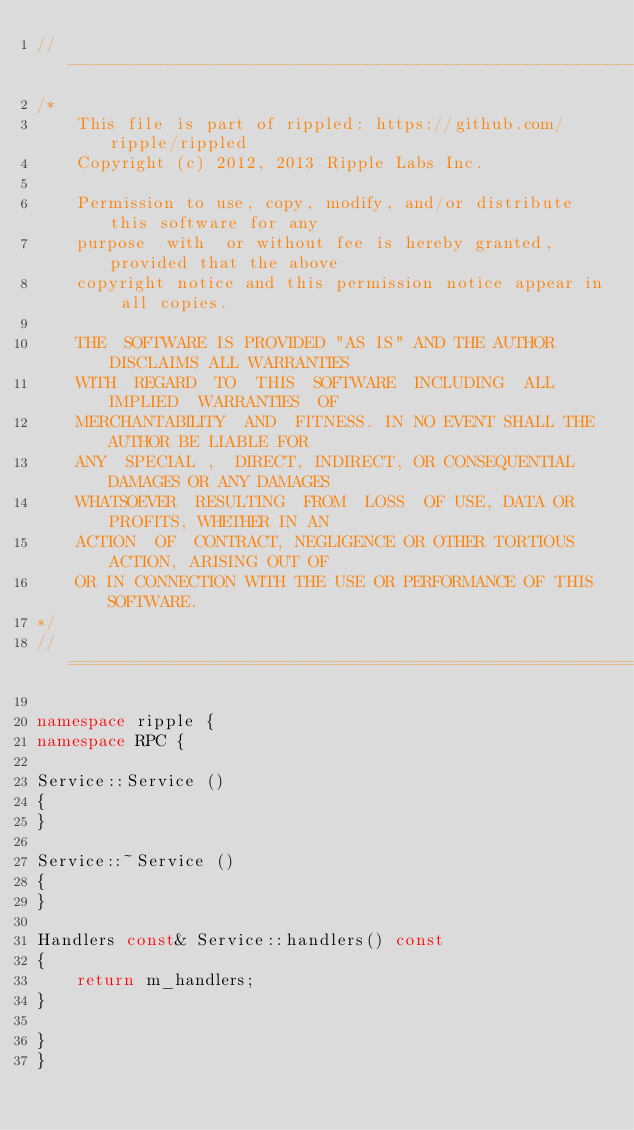<code> <loc_0><loc_0><loc_500><loc_500><_C++_>//------------------------------------------------------------------------------
/*
    This file is part of rippled: https://github.com/ripple/rippled
    Copyright (c) 2012, 2013 Ripple Labs Inc.

    Permission to use, copy, modify, and/or distribute this software for any
    purpose  with  or without fee is hereby granted, provided that the above
    copyright notice and this permission notice appear in all copies.

    THE  SOFTWARE IS PROVIDED "AS IS" AND THE AUTHOR DISCLAIMS ALL WARRANTIES
    WITH  REGARD  TO  THIS  SOFTWARE  INCLUDING  ALL  IMPLIED  WARRANTIES  OF
    MERCHANTABILITY  AND  FITNESS. IN NO EVENT SHALL THE AUTHOR BE LIABLE FOR
    ANY  SPECIAL ,  DIRECT, INDIRECT, OR CONSEQUENTIAL DAMAGES OR ANY DAMAGES
    WHATSOEVER  RESULTING  FROM  LOSS  OF USE, DATA OR PROFITS, WHETHER IN AN
    ACTION  OF  CONTRACT, NEGLIGENCE OR OTHER TORTIOUS ACTION, ARISING OUT OF
    OR IN CONNECTION WITH THE USE OR PERFORMANCE OF THIS SOFTWARE.
*/
//==============================================================================

namespace ripple {
namespace RPC {

Service::Service ()
{
}

Service::~Service ()
{
}

Handlers const& Service::handlers() const
{
    return m_handlers;
}

}
}
</code> 